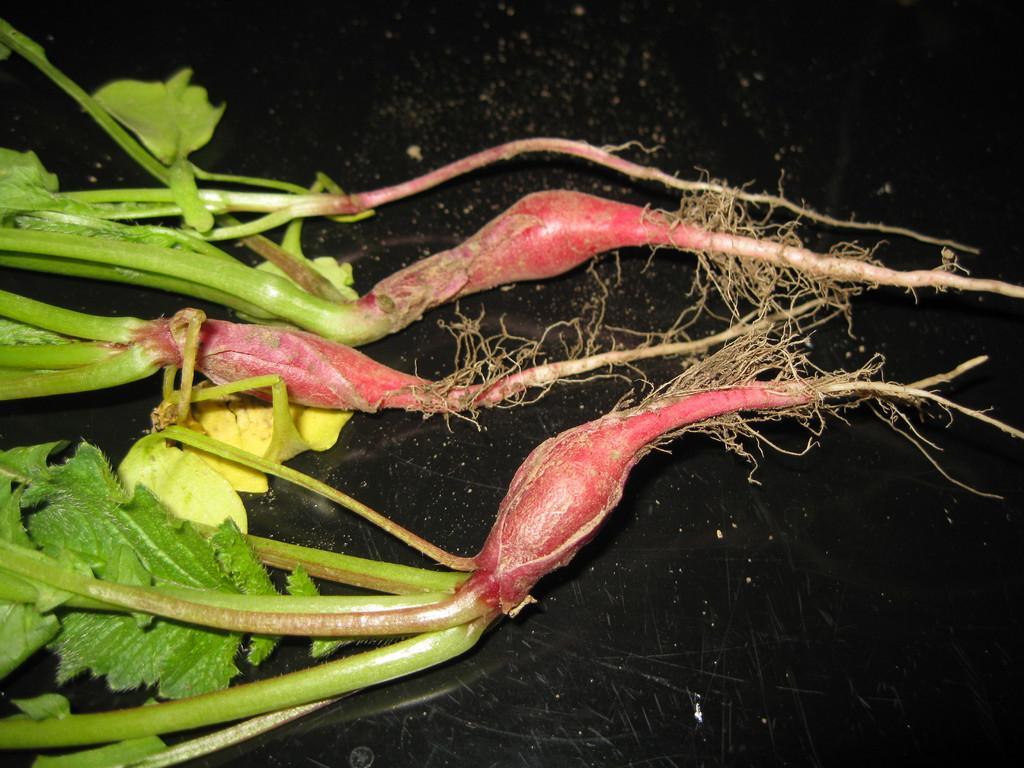In one or two sentences, can you explain what this image depicts? In this image I can see vegetable plants on a black color surface. 